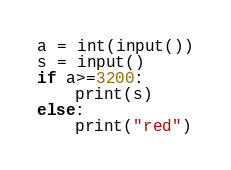Convert code to text. <code><loc_0><loc_0><loc_500><loc_500><_Python_>a = int(input())
s = input()
if a>=3200:
    print(s)
else:
    print("red")</code> 